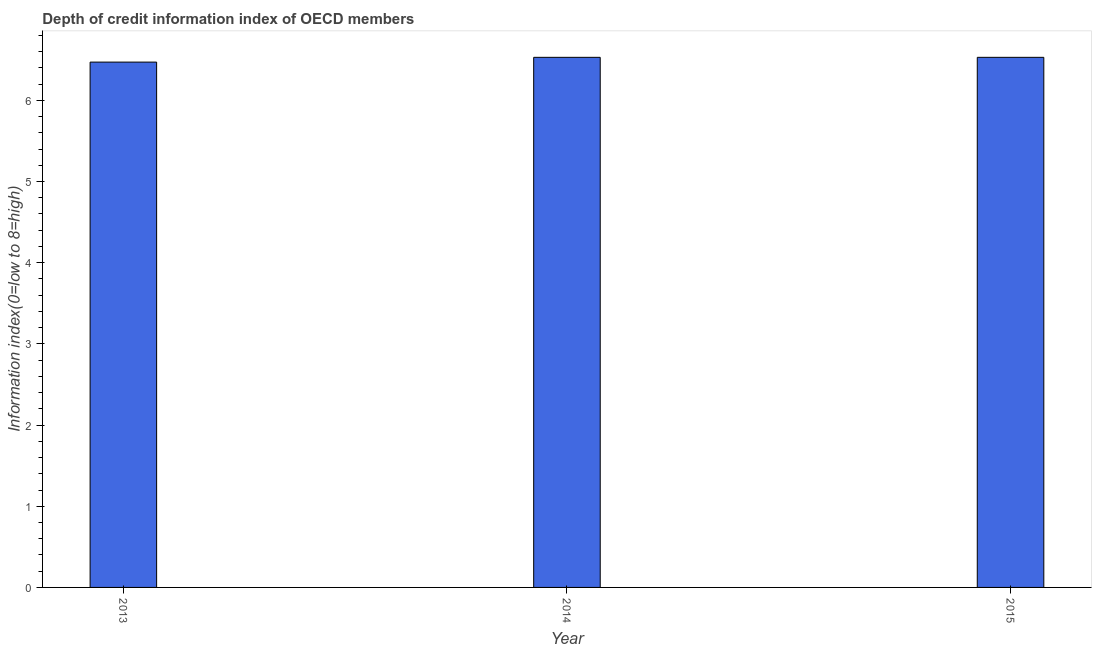Does the graph contain any zero values?
Your answer should be very brief. No. What is the title of the graph?
Offer a very short reply. Depth of credit information index of OECD members. What is the label or title of the X-axis?
Ensure brevity in your answer.  Year. What is the label or title of the Y-axis?
Your answer should be compact. Information index(0=low to 8=high). What is the depth of credit information index in 2015?
Provide a short and direct response. 6.53. Across all years, what is the maximum depth of credit information index?
Provide a succinct answer. 6.53. Across all years, what is the minimum depth of credit information index?
Your response must be concise. 6.47. In which year was the depth of credit information index maximum?
Provide a short and direct response. 2014. What is the sum of the depth of credit information index?
Keep it short and to the point. 19.53. What is the difference between the depth of credit information index in 2013 and 2015?
Your answer should be very brief. -0.06. What is the average depth of credit information index per year?
Offer a very short reply. 6.51. What is the median depth of credit information index?
Ensure brevity in your answer.  6.53. In how many years, is the depth of credit information index greater than 4.8 ?
Give a very brief answer. 3. What is the ratio of the depth of credit information index in 2013 to that in 2014?
Provide a succinct answer. 0.99. Is the difference between the depth of credit information index in 2013 and 2014 greater than the difference between any two years?
Keep it short and to the point. Yes. How many bars are there?
Ensure brevity in your answer.  3. Are all the bars in the graph horizontal?
Your response must be concise. No. How many years are there in the graph?
Your answer should be compact. 3. What is the Information index(0=low to 8=high) in 2013?
Offer a very short reply. 6.47. What is the Information index(0=low to 8=high) of 2014?
Provide a succinct answer. 6.53. What is the Information index(0=low to 8=high) in 2015?
Keep it short and to the point. 6.53. What is the difference between the Information index(0=low to 8=high) in 2013 and 2014?
Ensure brevity in your answer.  -0.06. What is the difference between the Information index(0=low to 8=high) in 2013 and 2015?
Provide a succinct answer. -0.06. What is the difference between the Information index(0=low to 8=high) in 2014 and 2015?
Your answer should be compact. 0. What is the ratio of the Information index(0=low to 8=high) in 2013 to that in 2014?
Your answer should be very brief. 0.99. What is the ratio of the Information index(0=low to 8=high) in 2013 to that in 2015?
Your response must be concise. 0.99. What is the ratio of the Information index(0=low to 8=high) in 2014 to that in 2015?
Give a very brief answer. 1. 